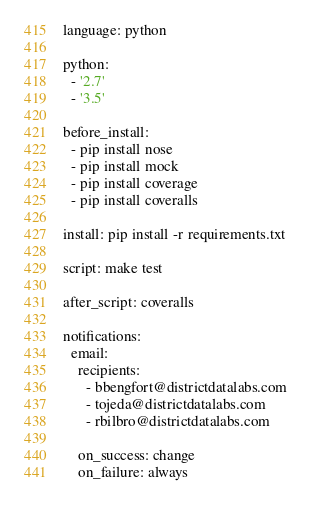<code> <loc_0><loc_0><loc_500><loc_500><_YAML_>
language: python

python:
  - '2.7'
  - '3.5'

before_install:
  - pip install nose
  - pip install mock
  - pip install coverage
  - pip install coveralls

install: pip install -r requirements.txt

script: make test

after_script: coveralls

notifications:
  email:
    recipients:
      - bbengfort@districtdatalabs.com
      - tojeda@districtdatalabs.com
      - rbilbro@districtdatalabs.com

    on_success: change
    on_failure: always
</code> 